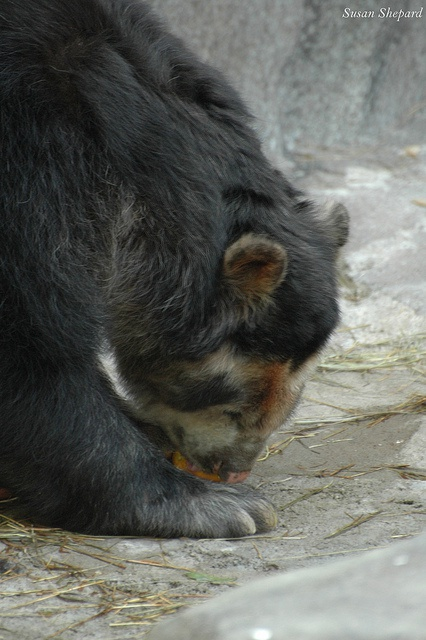Describe the objects in this image and their specific colors. I can see a bear in black, gray, and purple tones in this image. 